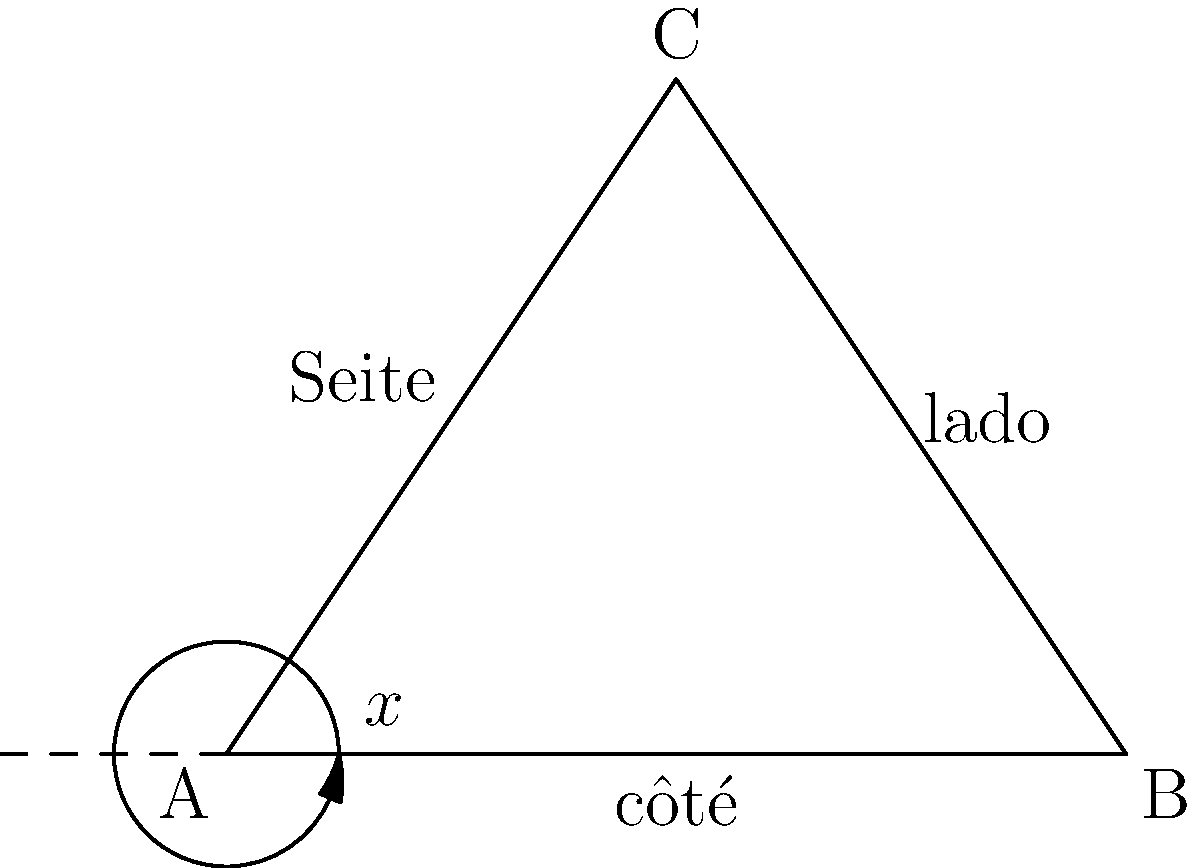In the triangle ABC, the sides are labeled in French (côté), Spanish (lado), and German (Seite). If the interior angles of the triangle are in the ratio 3:4:5, calculate the exterior angle $x°$ at vertex A. To solve this problem, let's follow these steps:

1) First, recall that the sum of interior angles of a triangle is always 180°.

2) Let's denote the angles as $3k$, $4k$, and $5k$, where $k$ is some constant. We can write:

   $3k + 4k + 5k = 180°$
   $12k = 180°$
   $k = 15°$

3) Now we can calculate each interior angle:
   - Angle at A: $3k = 3 * 15° = 45°$
   - Angle at B: $4k = 4 * 15° = 60°$
   - Angle at C: $5k = 5 * 15° = 75°$

4) Remember that an exterior angle of a triangle is supplementary to the corresponding interior angle. This means:

   exterior angle + interior angle = 180°

5) Therefore, for the exterior angle $x°$ at vertex A:

   $x° + 45° = 180°$
   $x° = 180° - 45° = 135°$

Thus, the exterior angle $x°$ at vertex A is 135°.
Answer: $135°$ 